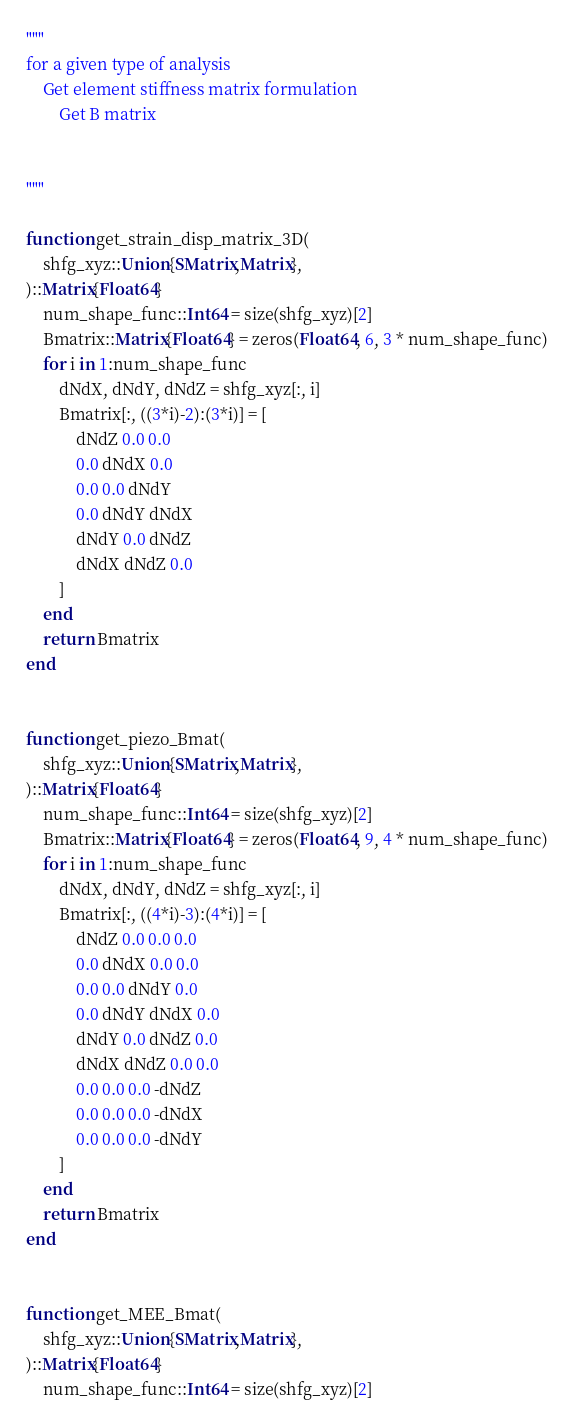<code> <loc_0><loc_0><loc_500><loc_500><_Julia_>"""
for a given type of analysis
    Get element stiffness matrix formulation
        Get B matrix


"""

function get_strain_disp_matrix_3D(
    shfg_xyz::Union{SMatrix,Matrix},
)::Matrix{Float64}
    num_shape_func::Int64 = size(shfg_xyz)[2]
    Bmatrix::Matrix{Float64} = zeros(Float64, 6, 3 * num_shape_func)
    for i in 1:num_shape_func
        dNdX, dNdY, dNdZ = shfg_xyz[:, i]
        Bmatrix[:, ((3*i)-2):(3*i)] = [
            dNdZ 0.0 0.0
            0.0 dNdX 0.0
            0.0 0.0 dNdY
            0.0 dNdY dNdX
            dNdY 0.0 dNdZ
            dNdX dNdZ 0.0
        ]
    end
    return Bmatrix
end


function get_piezo_Bmat(
    shfg_xyz::Union{SMatrix,Matrix},
)::Matrix{Float64}
    num_shape_func::Int64 = size(shfg_xyz)[2]
    Bmatrix::Matrix{Float64} = zeros(Float64, 9, 4 * num_shape_func)
    for i in 1:num_shape_func
        dNdX, dNdY, dNdZ = shfg_xyz[:, i]
        Bmatrix[:, ((4*i)-3):(4*i)] = [
            dNdZ 0.0 0.0 0.0
            0.0 dNdX 0.0 0.0
            0.0 0.0 dNdY 0.0
            0.0 dNdY dNdX 0.0
            dNdY 0.0 dNdZ 0.0
            dNdX dNdZ 0.0 0.0
            0.0 0.0 0.0 -dNdZ
            0.0 0.0 0.0 -dNdX
            0.0 0.0 0.0 -dNdY
        ]
    end
    return Bmatrix
end


function get_MEE_Bmat(
    shfg_xyz::Union{SMatrix,Matrix},
)::Matrix{Float64}
    num_shape_func::Int64 = size(shfg_xyz)[2]</code> 